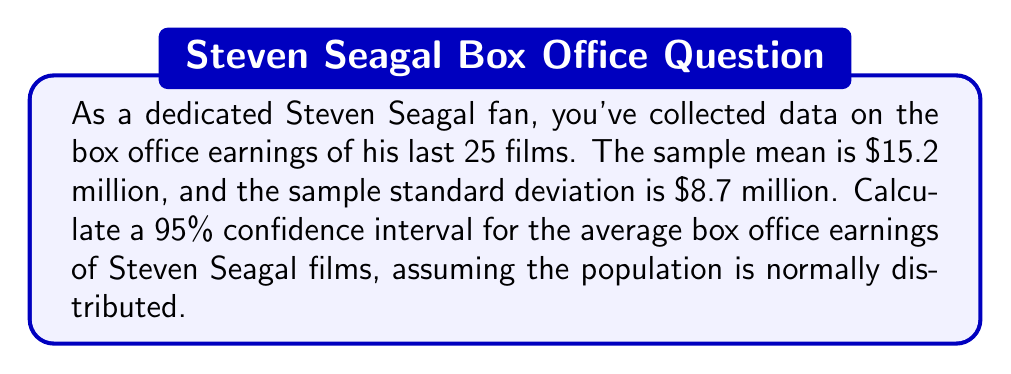Can you answer this question? Let's approach this step-by-step:

1) We're dealing with a sample size less than 30, so we'll use the t-distribution.

2) Given information:
   - Sample size: $n = 25$
   - Sample mean: $\bar{x} = 15.2$ million
   - Sample standard deviation: $s = 8.7$ million
   - Confidence level: 95%

3) The formula for the confidence interval is:

   $$\bar{x} \pm t_{\alpha/2, n-1} \cdot \frac{s}{\sqrt{n}}$$

4) For a 95% confidence interval, $\alpha = 0.05$, and $\alpha/2 = 0.025$

5) Degrees of freedom: $df = n - 1 = 24$

6) From the t-distribution table, $t_{0.025, 24} = 2.064$

7) Standard error: $\frac{s}{\sqrt{n}} = \frac{8.7}{\sqrt{25}} = 1.74$

8) Margin of error: $2.064 \cdot 1.74 = 3.59$

9) Therefore, the confidence interval is:

   $$15.2 \pm 3.59$$

   $$(11.61, 18.79)$$
Answer: $(11.61, 18.79)$ million 